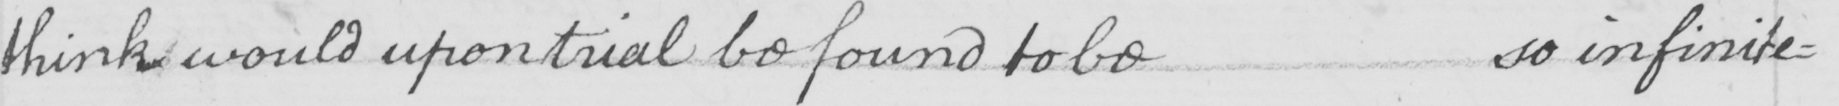What is written in this line of handwriting? think would upon trial be found to be so infinite= 